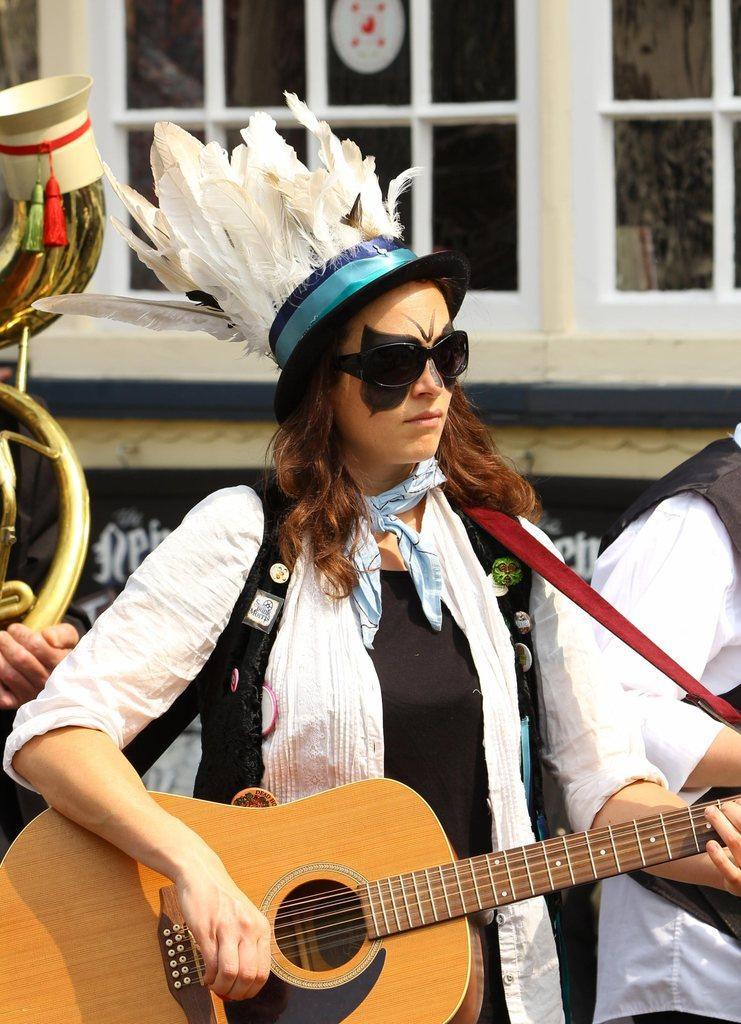Please provide a concise description of this image. In the middle there is a woman she is wearing white dress her hair is short she is playing guitar. On the right there is a person. In the background there a window and building. 